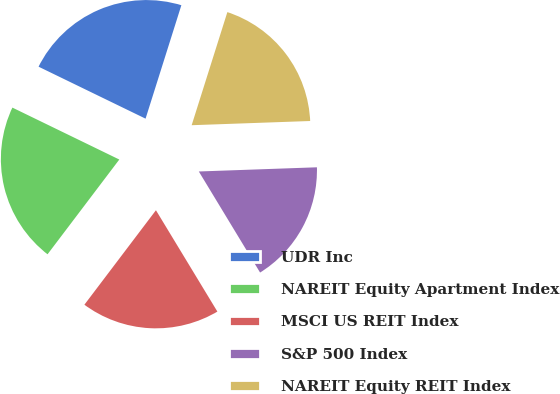<chart> <loc_0><loc_0><loc_500><loc_500><pie_chart><fcel>UDR Inc<fcel>NAREIT Equity Apartment Index<fcel>MSCI US REIT Index<fcel>S&P 500 Index<fcel>NAREIT Equity REIT Index<nl><fcel>22.67%<fcel>21.88%<fcel>18.99%<fcel>16.89%<fcel>19.57%<nl></chart> 